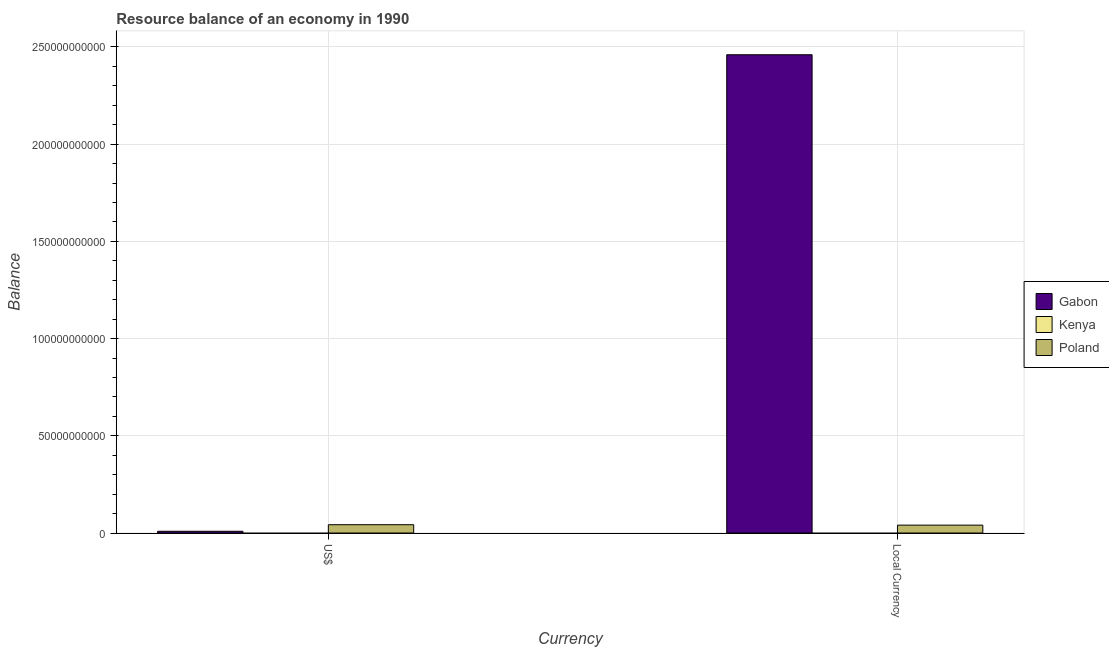How many different coloured bars are there?
Offer a terse response. 2. How many groups of bars are there?
Provide a succinct answer. 2. Are the number of bars per tick equal to the number of legend labels?
Offer a terse response. No. Are the number of bars on each tick of the X-axis equal?
Give a very brief answer. Yes. How many bars are there on the 1st tick from the left?
Provide a short and direct response. 2. How many bars are there on the 2nd tick from the right?
Offer a very short reply. 2. What is the label of the 1st group of bars from the left?
Your answer should be very brief. US$. What is the resource balance in us$ in Gabon?
Provide a succinct answer. 9.04e+08. Across all countries, what is the maximum resource balance in us$?
Provide a succinct answer. 4.27e+09. What is the total resource balance in constant us$ in the graph?
Offer a terse response. 2.50e+11. What is the difference between the resource balance in constant us$ in Gabon and that in Poland?
Provide a succinct answer. 2.42e+11. What is the difference between the resource balance in constant us$ in Kenya and the resource balance in us$ in Gabon?
Provide a succinct answer. -9.04e+08. What is the average resource balance in constant us$ per country?
Your answer should be very brief. 8.34e+1. What is the difference between the resource balance in constant us$ and resource balance in us$ in Gabon?
Keep it short and to the point. 2.45e+11. What is the ratio of the resource balance in us$ in Poland to that in Gabon?
Offer a very short reply. 4.73. What is the difference between two consecutive major ticks on the Y-axis?
Give a very brief answer. 5.00e+1. How many legend labels are there?
Give a very brief answer. 3. How are the legend labels stacked?
Provide a succinct answer. Vertical. What is the title of the graph?
Give a very brief answer. Resource balance of an economy in 1990. Does "Moldova" appear as one of the legend labels in the graph?
Your answer should be very brief. No. What is the label or title of the X-axis?
Your answer should be very brief. Currency. What is the label or title of the Y-axis?
Provide a short and direct response. Balance. What is the Balance in Gabon in US$?
Ensure brevity in your answer.  9.04e+08. What is the Balance in Kenya in US$?
Provide a succinct answer. 0. What is the Balance of Poland in US$?
Offer a terse response. 4.27e+09. What is the Balance in Gabon in Local Currency?
Offer a terse response. 2.46e+11. What is the Balance of Poland in Local Currency?
Give a very brief answer. 4.06e+09. Across all Currency, what is the maximum Balance of Gabon?
Make the answer very short. 2.46e+11. Across all Currency, what is the maximum Balance in Poland?
Offer a very short reply. 4.27e+09. Across all Currency, what is the minimum Balance of Gabon?
Keep it short and to the point. 9.04e+08. Across all Currency, what is the minimum Balance of Poland?
Your answer should be very brief. 4.06e+09. What is the total Balance of Gabon in the graph?
Keep it short and to the point. 2.47e+11. What is the total Balance of Kenya in the graph?
Offer a terse response. 0. What is the total Balance of Poland in the graph?
Ensure brevity in your answer.  8.34e+09. What is the difference between the Balance in Gabon in US$ and that in Local Currency?
Your answer should be very brief. -2.45e+11. What is the difference between the Balance of Poland in US$ and that in Local Currency?
Offer a terse response. 2.14e+08. What is the difference between the Balance of Gabon in US$ and the Balance of Poland in Local Currency?
Keep it short and to the point. -3.16e+09. What is the average Balance in Gabon per Currency?
Offer a terse response. 1.23e+11. What is the average Balance of Kenya per Currency?
Provide a short and direct response. 0. What is the average Balance in Poland per Currency?
Make the answer very short. 4.17e+09. What is the difference between the Balance in Gabon and Balance in Poland in US$?
Your answer should be compact. -3.37e+09. What is the difference between the Balance in Gabon and Balance in Poland in Local Currency?
Offer a terse response. 2.42e+11. What is the ratio of the Balance of Gabon in US$ to that in Local Currency?
Provide a short and direct response. 0. What is the ratio of the Balance in Poland in US$ to that in Local Currency?
Provide a succinct answer. 1.05. What is the difference between the highest and the second highest Balance of Gabon?
Ensure brevity in your answer.  2.45e+11. What is the difference between the highest and the second highest Balance in Poland?
Your response must be concise. 2.14e+08. What is the difference between the highest and the lowest Balance of Gabon?
Offer a very short reply. 2.45e+11. What is the difference between the highest and the lowest Balance in Poland?
Provide a short and direct response. 2.14e+08. 